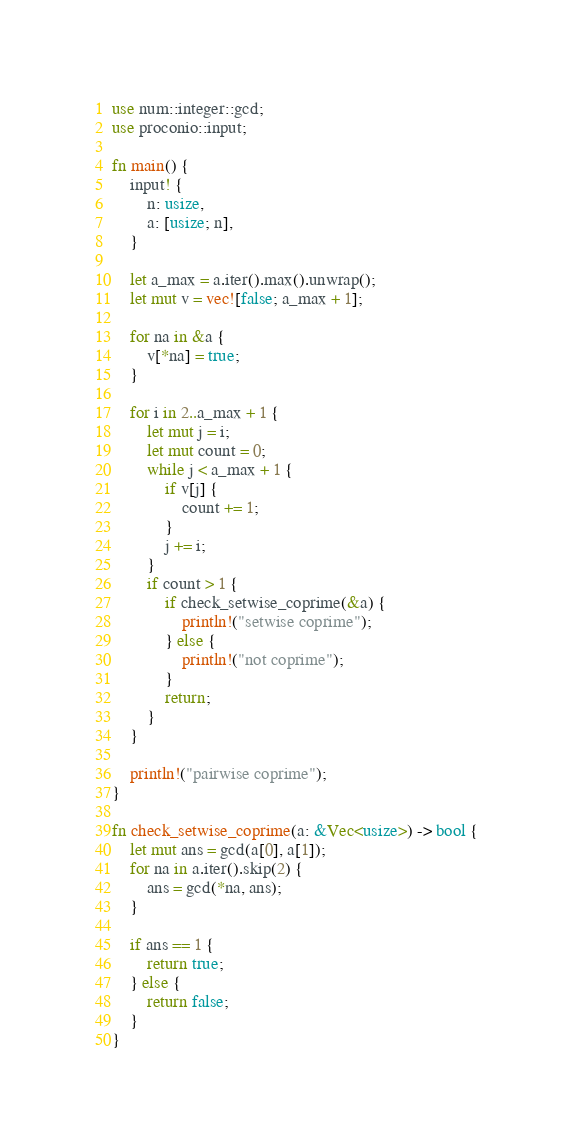Convert code to text. <code><loc_0><loc_0><loc_500><loc_500><_Rust_>use num::integer::gcd;
use proconio::input;

fn main() {
    input! {
        n: usize,
        a: [usize; n],
    }

    let a_max = a.iter().max().unwrap();
    let mut v = vec![false; a_max + 1];

    for na in &a {
        v[*na] = true;
    }

    for i in 2..a_max + 1 {
        let mut j = i;
        let mut count = 0;
        while j < a_max + 1 {
            if v[j] {
                count += 1;
            }
            j += i;
        }
        if count > 1 {
            if check_setwise_coprime(&a) {
                println!("setwise coprime");
            } else {
                println!("not coprime");
            }
            return;
        }
    }

    println!("pairwise coprime");
}

fn check_setwise_coprime(a: &Vec<usize>) -> bool {
    let mut ans = gcd(a[0], a[1]);
    for na in a.iter().skip(2) {
        ans = gcd(*na, ans);
    }

    if ans == 1 {
        return true;
    } else {
        return false;
    }
}
</code> 